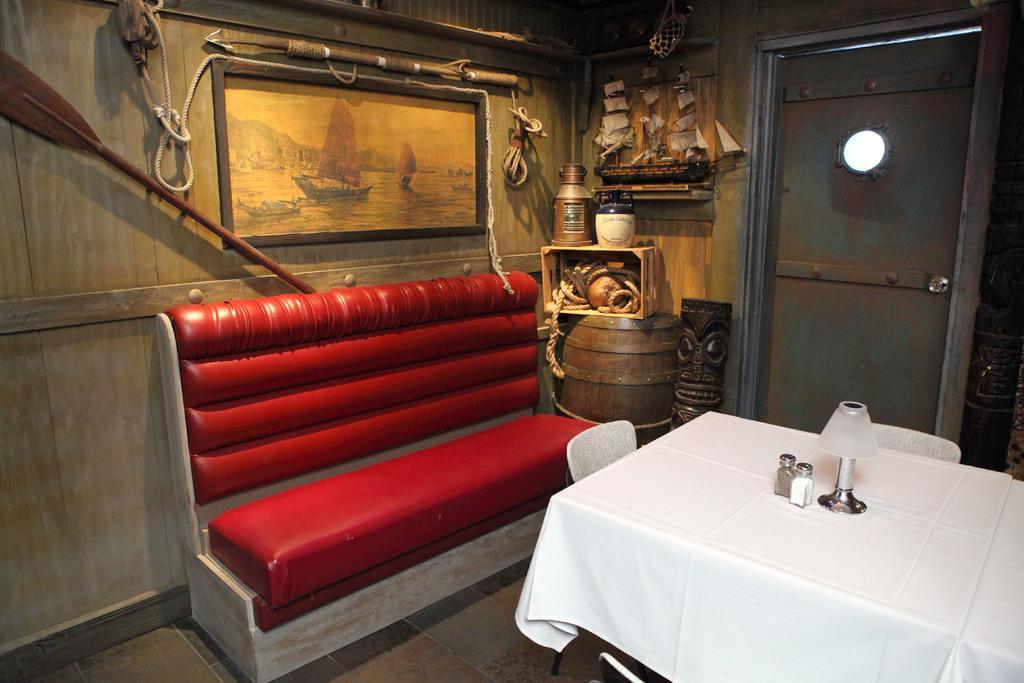In one or two sentences, can you explain what this image depicts? Picture is taken in the room which has sofa,table,chairs,frame,box,rope,ship toy in it. 